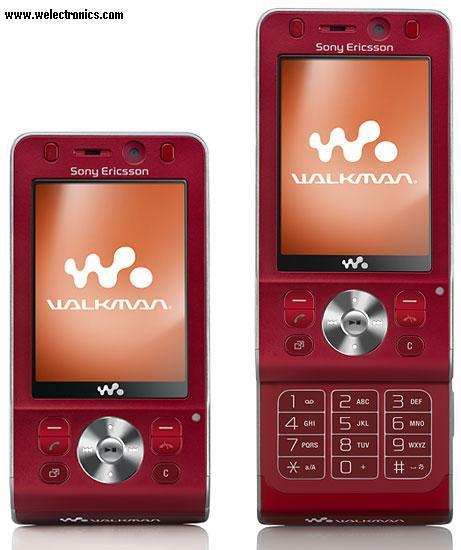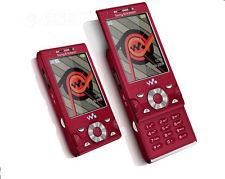The first image is the image on the left, the second image is the image on the right. Assess this claim about the two images: "There are only two phones.". Correct or not? Answer yes or no. No. The first image is the image on the left, the second image is the image on the right. Evaluate the accuracy of this statement regarding the images: "There are exactly two phones.". Is it true? Answer yes or no. No. 